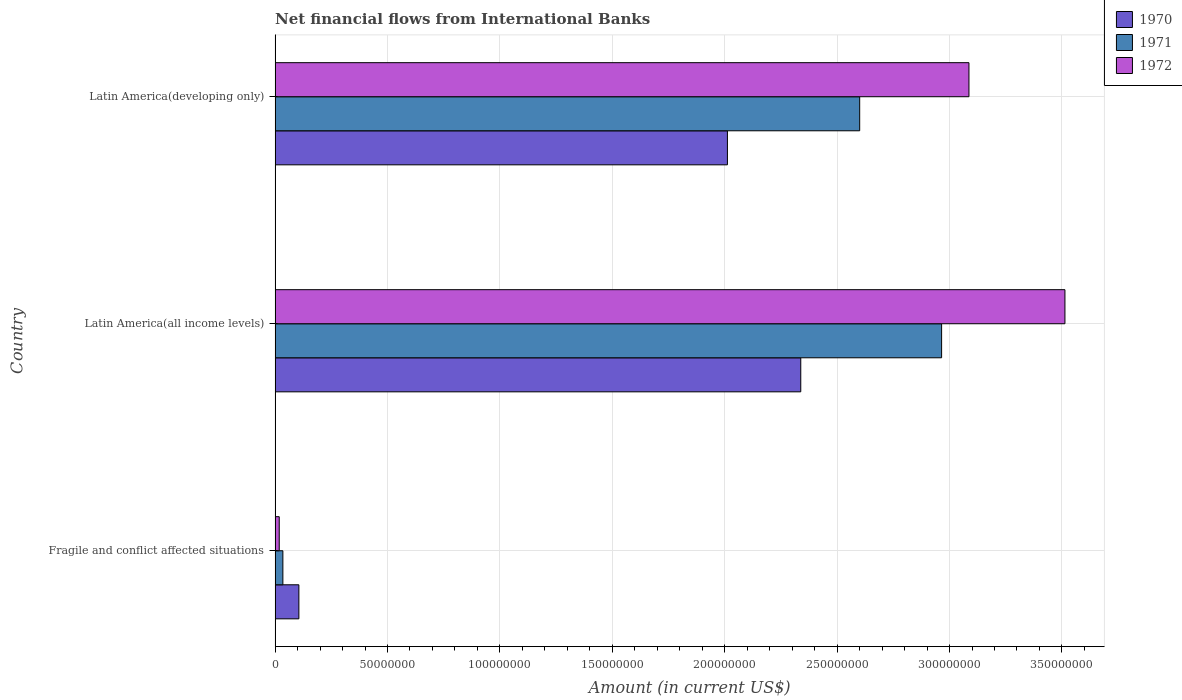How many different coloured bars are there?
Ensure brevity in your answer.  3. How many groups of bars are there?
Offer a terse response. 3. Are the number of bars per tick equal to the number of legend labels?
Offer a very short reply. Yes. How many bars are there on the 3rd tick from the top?
Your answer should be compact. 3. How many bars are there on the 3rd tick from the bottom?
Provide a short and direct response. 3. What is the label of the 1st group of bars from the top?
Make the answer very short. Latin America(developing only). In how many cases, is the number of bars for a given country not equal to the number of legend labels?
Your response must be concise. 0. What is the net financial aid flows in 1970 in Latin America(all income levels)?
Make the answer very short. 2.34e+08. Across all countries, what is the maximum net financial aid flows in 1970?
Your response must be concise. 2.34e+08. Across all countries, what is the minimum net financial aid flows in 1972?
Offer a very short reply. 1.85e+06. In which country was the net financial aid flows in 1972 maximum?
Offer a terse response. Latin America(all income levels). In which country was the net financial aid flows in 1971 minimum?
Your response must be concise. Fragile and conflict affected situations. What is the total net financial aid flows in 1970 in the graph?
Keep it short and to the point. 4.46e+08. What is the difference between the net financial aid flows in 1971 in Fragile and conflict affected situations and that in Latin America(developing only)?
Your answer should be very brief. -2.57e+08. What is the difference between the net financial aid flows in 1972 in Latin America(developing only) and the net financial aid flows in 1971 in Fragile and conflict affected situations?
Your response must be concise. 3.05e+08. What is the average net financial aid flows in 1971 per country?
Provide a succinct answer. 1.87e+08. What is the difference between the net financial aid flows in 1970 and net financial aid flows in 1972 in Fragile and conflict affected situations?
Give a very brief answer. 8.74e+06. What is the ratio of the net financial aid flows in 1971 in Fragile and conflict affected situations to that in Latin America(developing only)?
Your answer should be compact. 0.01. What is the difference between the highest and the second highest net financial aid flows in 1971?
Keep it short and to the point. 3.64e+07. What is the difference between the highest and the lowest net financial aid flows in 1972?
Your response must be concise. 3.49e+08. What does the 3rd bar from the bottom in Fragile and conflict affected situations represents?
Offer a very short reply. 1972. Is it the case that in every country, the sum of the net financial aid flows in 1971 and net financial aid flows in 1972 is greater than the net financial aid flows in 1970?
Ensure brevity in your answer.  No. How many bars are there?
Give a very brief answer. 9. Are all the bars in the graph horizontal?
Your response must be concise. Yes. How many countries are there in the graph?
Your answer should be compact. 3. Are the values on the major ticks of X-axis written in scientific E-notation?
Make the answer very short. No. Does the graph contain grids?
Keep it short and to the point. Yes. How many legend labels are there?
Your answer should be very brief. 3. What is the title of the graph?
Offer a terse response. Net financial flows from International Banks. Does "1984" appear as one of the legend labels in the graph?
Your response must be concise. No. What is the Amount (in current US$) in 1970 in Fragile and conflict affected situations?
Offer a terse response. 1.06e+07. What is the Amount (in current US$) of 1971 in Fragile and conflict affected situations?
Give a very brief answer. 3.47e+06. What is the Amount (in current US$) in 1972 in Fragile and conflict affected situations?
Offer a very short reply. 1.85e+06. What is the Amount (in current US$) of 1970 in Latin America(all income levels)?
Offer a terse response. 2.34e+08. What is the Amount (in current US$) of 1971 in Latin America(all income levels)?
Your answer should be very brief. 2.96e+08. What is the Amount (in current US$) of 1972 in Latin America(all income levels)?
Provide a succinct answer. 3.51e+08. What is the Amount (in current US$) in 1970 in Latin America(developing only)?
Keep it short and to the point. 2.01e+08. What is the Amount (in current US$) of 1971 in Latin America(developing only)?
Offer a very short reply. 2.60e+08. What is the Amount (in current US$) of 1972 in Latin America(developing only)?
Your answer should be very brief. 3.09e+08. Across all countries, what is the maximum Amount (in current US$) in 1970?
Keep it short and to the point. 2.34e+08. Across all countries, what is the maximum Amount (in current US$) in 1971?
Keep it short and to the point. 2.96e+08. Across all countries, what is the maximum Amount (in current US$) of 1972?
Provide a short and direct response. 3.51e+08. Across all countries, what is the minimum Amount (in current US$) in 1970?
Your answer should be very brief. 1.06e+07. Across all countries, what is the minimum Amount (in current US$) of 1971?
Your answer should be compact. 3.47e+06. Across all countries, what is the minimum Amount (in current US$) of 1972?
Make the answer very short. 1.85e+06. What is the total Amount (in current US$) in 1970 in the graph?
Your answer should be compact. 4.46e+08. What is the total Amount (in current US$) in 1971 in the graph?
Make the answer very short. 5.60e+08. What is the total Amount (in current US$) in 1972 in the graph?
Offer a terse response. 6.62e+08. What is the difference between the Amount (in current US$) of 1970 in Fragile and conflict affected situations and that in Latin America(all income levels)?
Provide a short and direct response. -2.23e+08. What is the difference between the Amount (in current US$) in 1971 in Fragile and conflict affected situations and that in Latin America(all income levels)?
Provide a short and direct response. -2.93e+08. What is the difference between the Amount (in current US$) in 1972 in Fragile and conflict affected situations and that in Latin America(all income levels)?
Provide a short and direct response. -3.49e+08. What is the difference between the Amount (in current US$) of 1970 in Fragile and conflict affected situations and that in Latin America(developing only)?
Offer a terse response. -1.91e+08. What is the difference between the Amount (in current US$) of 1971 in Fragile and conflict affected situations and that in Latin America(developing only)?
Ensure brevity in your answer.  -2.57e+08. What is the difference between the Amount (in current US$) of 1972 in Fragile and conflict affected situations and that in Latin America(developing only)?
Offer a very short reply. -3.07e+08. What is the difference between the Amount (in current US$) of 1970 in Latin America(all income levels) and that in Latin America(developing only)?
Offer a very short reply. 3.26e+07. What is the difference between the Amount (in current US$) in 1971 in Latin America(all income levels) and that in Latin America(developing only)?
Provide a succinct answer. 3.64e+07. What is the difference between the Amount (in current US$) of 1972 in Latin America(all income levels) and that in Latin America(developing only)?
Make the answer very short. 4.27e+07. What is the difference between the Amount (in current US$) in 1970 in Fragile and conflict affected situations and the Amount (in current US$) in 1971 in Latin America(all income levels)?
Offer a terse response. -2.86e+08. What is the difference between the Amount (in current US$) in 1970 in Fragile and conflict affected situations and the Amount (in current US$) in 1972 in Latin America(all income levels)?
Your response must be concise. -3.41e+08. What is the difference between the Amount (in current US$) in 1971 in Fragile and conflict affected situations and the Amount (in current US$) in 1972 in Latin America(all income levels)?
Give a very brief answer. -3.48e+08. What is the difference between the Amount (in current US$) in 1970 in Fragile and conflict affected situations and the Amount (in current US$) in 1971 in Latin America(developing only)?
Provide a succinct answer. -2.49e+08. What is the difference between the Amount (in current US$) in 1970 in Fragile and conflict affected situations and the Amount (in current US$) in 1972 in Latin America(developing only)?
Provide a succinct answer. -2.98e+08. What is the difference between the Amount (in current US$) in 1971 in Fragile and conflict affected situations and the Amount (in current US$) in 1972 in Latin America(developing only)?
Make the answer very short. -3.05e+08. What is the difference between the Amount (in current US$) in 1970 in Latin America(all income levels) and the Amount (in current US$) in 1971 in Latin America(developing only)?
Your response must be concise. -2.62e+07. What is the difference between the Amount (in current US$) in 1970 in Latin America(all income levels) and the Amount (in current US$) in 1972 in Latin America(developing only)?
Ensure brevity in your answer.  -7.48e+07. What is the difference between the Amount (in current US$) of 1971 in Latin America(all income levels) and the Amount (in current US$) of 1972 in Latin America(developing only)?
Give a very brief answer. -1.22e+07. What is the average Amount (in current US$) in 1970 per country?
Provide a short and direct response. 1.49e+08. What is the average Amount (in current US$) of 1971 per country?
Provide a short and direct response. 1.87e+08. What is the average Amount (in current US$) in 1972 per country?
Give a very brief answer. 2.21e+08. What is the difference between the Amount (in current US$) in 1970 and Amount (in current US$) in 1971 in Fragile and conflict affected situations?
Your answer should be very brief. 7.12e+06. What is the difference between the Amount (in current US$) in 1970 and Amount (in current US$) in 1972 in Fragile and conflict affected situations?
Offer a very short reply. 8.74e+06. What is the difference between the Amount (in current US$) in 1971 and Amount (in current US$) in 1972 in Fragile and conflict affected situations?
Your answer should be very brief. 1.62e+06. What is the difference between the Amount (in current US$) of 1970 and Amount (in current US$) of 1971 in Latin America(all income levels)?
Your answer should be very brief. -6.26e+07. What is the difference between the Amount (in current US$) of 1970 and Amount (in current US$) of 1972 in Latin America(all income levels)?
Give a very brief answer. -1.18e+08. What is the difference between the Amount (in current US$) in 1971 and Amount (in current US$) in 1972 in Latin America(all income levels)?
Your answer should be very brief. -5.49e+07. What is the difference between the Amount (in current US$) of 1970 and Amount (in current US$) of 1971 in Latin America(developing only)?
Your answer should be compact. -5.88e+07. What is the difference between the Amount (in current US$) in 1970 and Amount (in current US$) in 1972 in Latin America(developing only)?
Give a very brief answer. -1.07e+08. What is the difference between the Amount (in current US$) of 1971 and Amount (in current US$) of 1972 in Latin America(developing only)?
Ensure brevity in your answer.  -4.86e+07. What is the ratio of the Amount (in current US$) in 1970 in Fragile and conflict affected situations to that in Latin America(all income levels)?
Provide a succinct answer. 0.05. What is the ratio of the Amount (in current US$) of 1971 in Fragile and conflict affected situations to that in Latin America(all income levels)?
Make the answer very short. 0.01. What is the ratio of the Amount (in current US$) of 1972 in Fragile and conflict affected situations to that in Latin America(all income levels)?
Give a very brief answer. 0.01. What is the ratio of the Amount (in current US$) in 1970 in Fragile and conflict affected situations to that in Latin America(developing only)?
Keep it short and to the point. 0.05. What is the ratio of the Amount (in current US$) in 1971 in Fragile and conflict affected situations to that in Latin America(developing only)?
Offer a very short reply. 0.01. What is the ratio of the Amount (in current US$) of 1972 in Fragile and conflict affected situations to that in Latin America(developing only)?
Offer a very short reply. 0.01. What is the ratio of the Amount (in current US$) in 1970 in Latin America(all income levels) to that in Latin America(developing only)?
Give a very brief answer. 1.16. What is the ratio of the Amount (in current US$) of 1971 in Latin America(all income levels) to that in Latin America(developing only)?
Offer a very short reply. 1.14. What is the ratio of the Amount (in current US$) in 1972 in Latin America(all income levels) to that in Latin America(developing only)?
Provide a succinct answer. 1.14. What is the difference between the highest and the second highest Amount (in current US$) in 1970?
Your answer should be very brief. 3.26e+07. What is the difference between the highest and the second highest Amount (in current US$) in 1971?
Provide a short and direct response. 3.64e+07. What is the difference between the highest and the second highest Amount (in current US$) in 1972?
Provide a succinct answer. 4.27e+07. What is the difference between the highest and the lowest Amount (in current US$) of 1970?
Keep it short and to the point. 2.23e+08. What is the difference between the highest and the lowest Amount (in current US$) of 1971?
Your answer should be very brief. 2.93e+08. What is the difference between the highest and the lowest Amount (in current US$) of 1972?
Offer a terse response. 3.49e+08. 